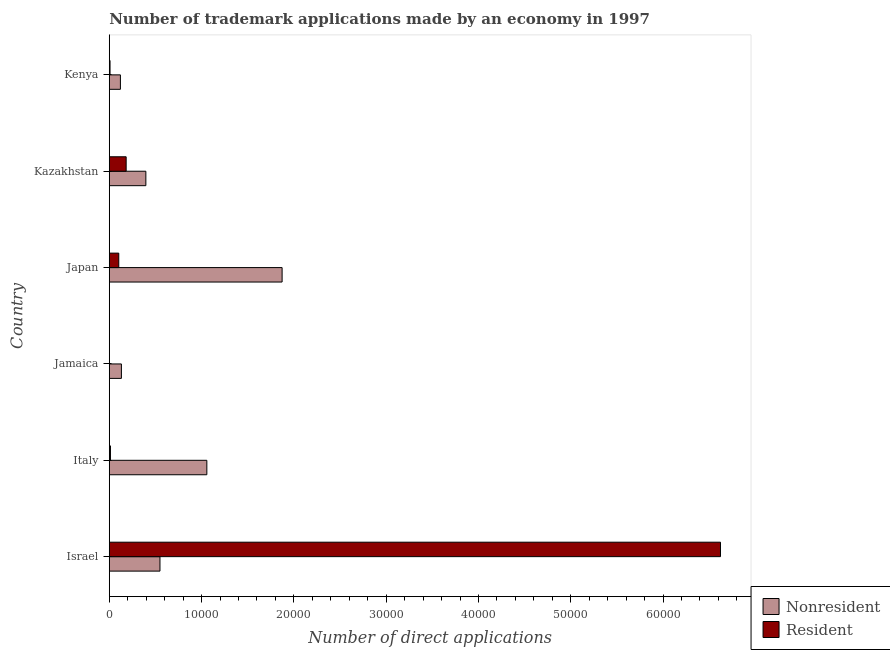How many different coloured bars are there?
Ensure brevity in your answer.  2. How many bars are there on the 1st tick from the top?
Ensure brevity in your answer.  2. How many bars are there on the 6th tick from the bottom?
Offer a terse response. 2. What is the label of the 2nd group of bars from the top?
Your answer should be compact. Kazakhstan. What is the number of trademark applications made by non residents in Kazakhstan?
Provide a succinct answer. 3964. Across all countries, what is the maximum number of trademark applications made by residents?
Your answer should be very brief. 6.62e+04. Across all countries, what is the minimum number of trademark applications made by non residents?
Provide a short and direct response. 1207. In which country was the number of trademark applications made by residents maximum?
Your response must be concise. Israel. In which country was the number of trademark applications made by non residents minimum?
Provide a succinct answer. Kenya. What is the total number of trademark applications made by non residents in the graph?
Provide a short and direct response. 4.13e+04. What is the difference between the number of trademark applications made by residents in Japan and that in Kenya?
Give a very brief answer. 947. What is the difference between the number of trademark applications made by non residents in Israel and the number of trademark applications made by residents in Italy?
Your response must be concise. 5365. What is the average number of trademark applications made by residents per country?
Ensure brevity in your answer.  1.16e+04. What is the difference between the number of trademark applications made by non residents and number of trademark applications made by residents in Israel?
Your answer should be very brief. -6.07e+04. In how many countries, is the number of trademark applications made by non residents greater than 6000 ?
Your response must be concise. 2. What is the ratio of the number of trademark applications made by residents in Israel to that in Japan?
Offer a terse response. 64.36. Is the difference between the number of trademark applications made by non residents in Italy and Kazakhstan greater than the difference between the number of trademark applications made by residents in Italy and Kazakhstan?
Ensure brevity in your answer.  Yes. What is the difference between the highest and the second highest number of trademark applications made by non residents?
Make the answer very short. 8156. What is the difference between the highest and the lowest number of trademark applications made by residents?
Offer a terse response. 6.62e+04. What does the 1st bar from the top in Kazakhstan represents?
Keep it short and to the point. Resident. What does the 2nd bar from the bottom in Kazakhstan represents?
Make the answer very short. Resident. How many bars are there?
Keep it short and to the point. 12. Are all the bars in the graph horizontal?
Provide a succinct answer. Yes. Does the graph contain grids?
Give a very brief answer. No. Where does the legend appear in the graph?
Offer a terse response. Bottom right. What is the title of the graph?
Ensure brevity in your answer.  Number of trademark applications made by an economy in 1997. What is the label or title of the X-axis?
Your answer should be compact. Number of direct applications. What is the label or title of the Y-axis?
Provide a succinct answer. Country. What is the Number of direct applications of Nonresident in Israel?
Provide a succinct answer. 5493. What is the Number of direct applications in Resident in Israel?
Your answer should be compact. 6.62e+04. What is the Number of direct applications of Nonresident in Italy?
Give a very brief answer. 1.06e+04. What is the Number of direct applications of Resident in Italy?
Provide a succinct answer. 128. What is the Number of direct applications of Nonresident in Jamaica?
Make the answer very short. 1315. What is the Number of direct applications of Nonresident in Japan?
Give a very brief answer. 1.87e+04. What is the Number of direct applications in Resident in Japan?
Provide a short and direct response. 1029. What is the Number of direct applications in Nonresident in Kazakhstan?
Your answer should be very brief. 3964. What is the Number of direct applications of Resident in Kazakhstan?
Keep it short and to the point. 1829. What is the Number of direct applications of Nonresident in Kenya?
Offer a very short reply. 1207. What is the Number of direct applications of Resident in Kenya?
Make the answer very short. 82. Across all countries, what is the maximum Number of direct applications in Nonresident?
Offer a very short reply. 1.87e+04. Across all countries, what is the maximum Number of direct applications in Resident?
Offer a terse response. 6.62e+04. Across all countries, what is the minimum Number of direct applications in Nonresident?
Ensure brevity in your answer.  1207. Across all countries, what is the minimum Number of direct applications of Resident?
Your response must be concise. 13. What is the total Number of direct applications of Nonresident in the graph?
Provide a short and direct response. 4.13e+04. What is the total Number of direct applications in Resident in the graph?
Give a very brief answer. 6.93e+04. What is the difference between the Number of direct applications of Nonresident in Israel and that in Italy?
Keep it short and to the point. -5078. What is the difference between the Number of direct applications in Resident in Israel and that in Italy?
Offer a terse response. 6.61e+04. What is the difference between the Number of direct applications of Nonresident in Israel and that in Jamaica?
Your response must be concise. 4178. What is the difference between the Number of direct applications in Resident in Israel and that in Jamaica?
Offer a very short reply. 6.62e+04. What is the difference between the Number of direct applications of Nonresident in Israel and that in Japan?
Make the answer very short. -1.32e+04. What is the difference between the Number of direct applications in Resident in Israel and that in Japan?
Your answer should be very brief. 6.52e+04. What is the difference between the Number of direct applications in Nonresident in Israel and that in Kazakhstan?
Ensure brevity in your answer.  1529. What is the difference between the Number of direct applications in Resident in Israel and that in Kazakhstan?
Offer a very short reply. 6.44e+04. What is the difference between the Number of direct applications of Nonresident in Israel and that in Kenya?
Offer a very short reply. 4286. What is the difference between the Number of direct applications of Resident in Israel and that in Kenya?
Offer a terse response. 6.61e+04. What is the difference between the Number of direct applications of Nonresident in Italy and that in Jamaica?
Provide a succinct answer. 9256. What is the difference between the Number of direct applications of Resident in Italy and that in Jamaica?
Give a very brief answer. 115. What is the difference between the Number of direct applications of Nonresident in Italy and that in Japan?
Provide a succinct answer. -8156. What is the difference between the Number of direct applications of Resident in Italy and that in Japan?
Keep it short and to the point. -901. What is the difference between the Number of direct applications in Nonresident in Italy and that in Kazakhstan?
Your answer should be very brief. 6607. What is the difference between the Number of direct applications in Resident in Italy and that in Kazakhstan?
Make the answer very short. -1701. What is the difference between the Number of direct applications in Nonresident in Italy and that in Kenya?
Offer a terse response. 9364. What is the difference between the Number of direct applications of Resident in Italy and that in Kenya?
Offer a terse response. 46. What is the difference between the Number of direct applications of Nonresident in Jamaica and that in Japan?
Provide a succinct answer. -1.74e+04. What is the difference between the Number of direct applications of Resident in Jamaica and that in Japan?
Give a very brief answer. -1016. What is the difference between the Number of direct applications of Nonresident in Jamaica and that in Kazakhstan?
Keep it short and to the point. -2649. What is the difference between the Number of direct applications in Resident in Jamaica and that in Kazakhstan?
Provide a succinct answer. -1816. What is the difference between the Number of direct applications of Nonresident in Jamaica and that in Kenya?
Offer a terse response. 108. What is the difference between the Number of direct applications in Resident in Jamaica and that in Kenya?
Ensure brevity in your answer.  -69. What is the difference between the Number of direct applications in Nonresident in Japan and that in Kazakhstan?
Offer a very short reply. 1.48e+04. What is the difference between the Number of direct applications of Resident in Japan and that in Kazakhstan?
Offer a terse response. -800. What is the difference between the Number of direct applications of Nonresident in Japan and that in Kenya?
Provide a short and direct response. 1.75e+04. What is the difference between the Number of direct applications of Resident in Japan and that in Kenya?
Your answer should be compact. 947. What is the difference between the Number of direct applications in Nonresident in Kazakhstan and that in Kenya?
Provide a short and direct response. 2757. What is the difference between the Number of direct applications in Resident in Kazakhstan and that in Kenya?
Make the answer very short. 1747. What is the difference between the Number of direct applications of Nonresident in Israel and the Number of direct applications of Resident in Italy?
Your answer should be very brief. 5365. What is the difference between the Number of direct applications in Nonresident in Israel and the Number of direct applications in Resident in Jamaica?
Offer a terse response. 5480. What is the difference between the Number of direct applications in Nonresident in Israel and the Number of direct applications in Resident in Japan?
Provide a succinct answer. 4464. What is the difference between the Number of direct applications of Nonresident in Israel and the Number of direct applications of Resident in Kazakhstan?
Provide a short and direct response. 3664. What is the difference between the Number of direct applications in Nonresident in Israel and the Number of direct applications in Resident in Kenya?
Offer a very short reply. 5411. What is the difference between the Number of direct applications in Nonresident in Italy and the Number of direct applications in Resident in Jamaica?
Your answer should be very brief. 1.06e+04. What is the difference between the Number of direct applications of Nonresident in Italy and the Number of direct applications of Resident in Japan?
Provide a short and direct response. 9542. What is the difference between the Number of direct applications of Nonresident in Italy and the Number of direct applications of Resident in Kazakhstan?
Your answer should be compact. 8742. What is the difference between the Number of direct applications in Nonresident in Italy and the Number of direct applications in Resident in Kenya?
Your answer should be compact. 1.05e+04. What is the difference between the Number of direct applications in Nonresident in Jamaica and the Number of direct applications in Resident in Japan?
Provide a succinct answer. 286. What is the difference between the Number of direct applications of Nonresident in Jamaica and the Number of direct applications of Resident in Kazakhstan?
Provide a succinct answer. -514. What is the difference between the Number of direct applications in Nonresident in Jamaica and the Number of direct applications in Resident in Kenya?
Give a very brief answer. 1233. What is the difference between the Number of direct applications in Nonresident in Japan and the Number of direct applications in Resident in Kazakhstan?
Your response must be concise. 1.69e+04. What is the difference between the Number of direct applications of Nonresident in Japan and the Number of direct applications of Resident in Kenya?
Keep it short and to the point. 1.86e+04. What is the difference between the Number of direct applications of Nonresident in Kazakhstan and the Number of direct applications of Resident in Kenya?
Provide a succinct answer. 3882. What is the average Number of direct applications in Nonresident per country?
Ensure brevity in your answer.  6879.5. What is the average Number of direct applications in Resident per country?
Keep it short and to the point. 1.16e+04. What is the difference between the Number of direct applications of Nonresident and Number of direct applications of Resident in Israel?
Provide a short and direct response. -6.07e+04. What is the difference between the Number of direct applications in Nonresident and Number of direct applications in Resident in Italy?
Keep it short and to the point. 1.04e+04. What is the difference between the Number of direct applications in Nonresident and Number of direct applications in Resident in Jamaica?
Your answer should be compact. 1302. What is the difference between the Number of direct applications of Nonresident and Number of direct applications of Resident in Japan?
Provide a succinct answer. 1.77e+04. What is the difference between the Number of direct applications in Nonresident and Number of direct applications in Resident in Kazakhstan?
Your response must be concise. 2135. What is the difference between the Number of direct applications in Nonresident and Number of direct applications in Resident in Kenya?
Make the answer very short. 1125. What is the ratio of the Number of direct applications in Nonresident in Israel to that in Italy?
Give a very brief answer. 0.52. What is the ratio of the Number of direct applications of Resident in Israel to that in Italy?
Offer a very short reply. 517.36. What is the ratio of the Number of direct applications of Nonresident in Israel to that in Jamaica?
Ensure brevity in your answer.  4.18. What is the ratio of the Number of direct applications in Resident in Israel to that in Jamaica?
Keep it short and to the point. 5094. What is the ratio of the Number of direct applications in Nonresident in Israel to that in Japan?
Your answer should be compact. 0.29. What is the ratio of the Number of direct applications in Resident in Israel to that in Japan?
Offer a terse response. 64.36. What is the ratio of the Number of direct applications in Nonresident in Israel to that in Kazakhstan?
Your response must be concise. 1.39. What is the ratio of the Number of direct applications in Resident in Israel to that in Kazakhstan?
Keep it short and to the point. 36.21. What is the ratio of the Number of direct applications of Nonresident in Israel to that in Kenya?
Make the answer very short. 4.55. What is the ratio of the Number of direct applications of Resident in Israel to that in Kenya?
Provide a short and direct response. 807.59. What is the ratio of the Number of direct applications in Nonresident in Italy to that in Jamaica?
Offer a very short reply. 8.04. What is the ratio of the Number of direct applications of Resident in Italy to that in Jamaica?
Provide a succinct answer. 9.85. What is the ratio of the Number of direct applications in Nonresident in Italy to that in Japan?
Make the answer very short. 0.56. What is the ratio of the Number of direct applications in Resident in Italy to that in Japan?
Your response must be concise. 0.12. What is the ratio of the Number of direct applications of Nonresident in Italy to that in Kazakhstan?
Provide a short and direct response. 2.67. What is the ratio of the Number of direct applications of Resident in Italy to that in Kazakhstan?
Your response must be concise. 0.07. What is the ratio of the Number of direct applications of Nonresident in Italy to that in Kenya?
Ensure brevity in your answer.  8.76. What is the ratio of the Number of direct applications in Resident in Italy to that in Kenya?
Your response must be concise. 1.56. What is the ratio of the Number of direct applications in Nonresident in Jamaica to that in Japan?
Give a very brief answer. 0.07. What is the ratio of the Number of direct applications in Resident in Jamaica to that in Japan?
Give a very brief answer. 0.01. What is the ratio of the Number of direct applications in Nonresident in Jamaica to that in Kazakhstan?
Give a very brief answer. 0.33. What is the ratio of the Number of direct applications in Resident in Jamaica to that in Kazakhstan?
Your response must be concise. 0.01. What is the ratio of the Number of direct applications in Nonresident in Jamaica to that in Kenya?
Your answer should be very brief. 1.09. What is the ratio of the Number of direct applications in Resident in Jamaica to that in Kenya?
Offer a terse response. 0.16. What is the ratio of the Number of direct applications in Nonresident in Japan to that in Kazakhstan?
Your answer should be compact. 4.72. What is the ratio of the Number of direct applications of Resident in Japan to that in Kazakhstan?
Make the answer very short. 0.56. What is the ratio of the Number of direct applications in Nonresident in Japan to that in Kenya?
Keep it short and to the point. 15.52. What is the ratio of the Number of direct applications in Resident in Japan to that in Kenya?
Your answer should be compact. 12.55. What is the ratio of the Number of direct applications of Nonresident in Kazakhstan to that in Kenya?
Provide a succinct answer. 3.28. What is the ratio of the Number of direct applications of Resident in Kazakhstan to that in Kenya?
Provide a succinct answer. 22.3. What is the difference between the highest and the second highest Number of direct applications of Nonresident?
Provide a short and direct response. 8156. What is the difference between the highest and the second highest Number of direct applications of Resident?
Your response must be concise. 6.44e+04. What is the difference between the highest and the lowest Number of direct applications in Nonresident?
Make the answer very short. 1.75e+04. What is the difference between the highest and the lowest Number of direct applications in Resident?
Make the answer very short. 6.62e+04. 